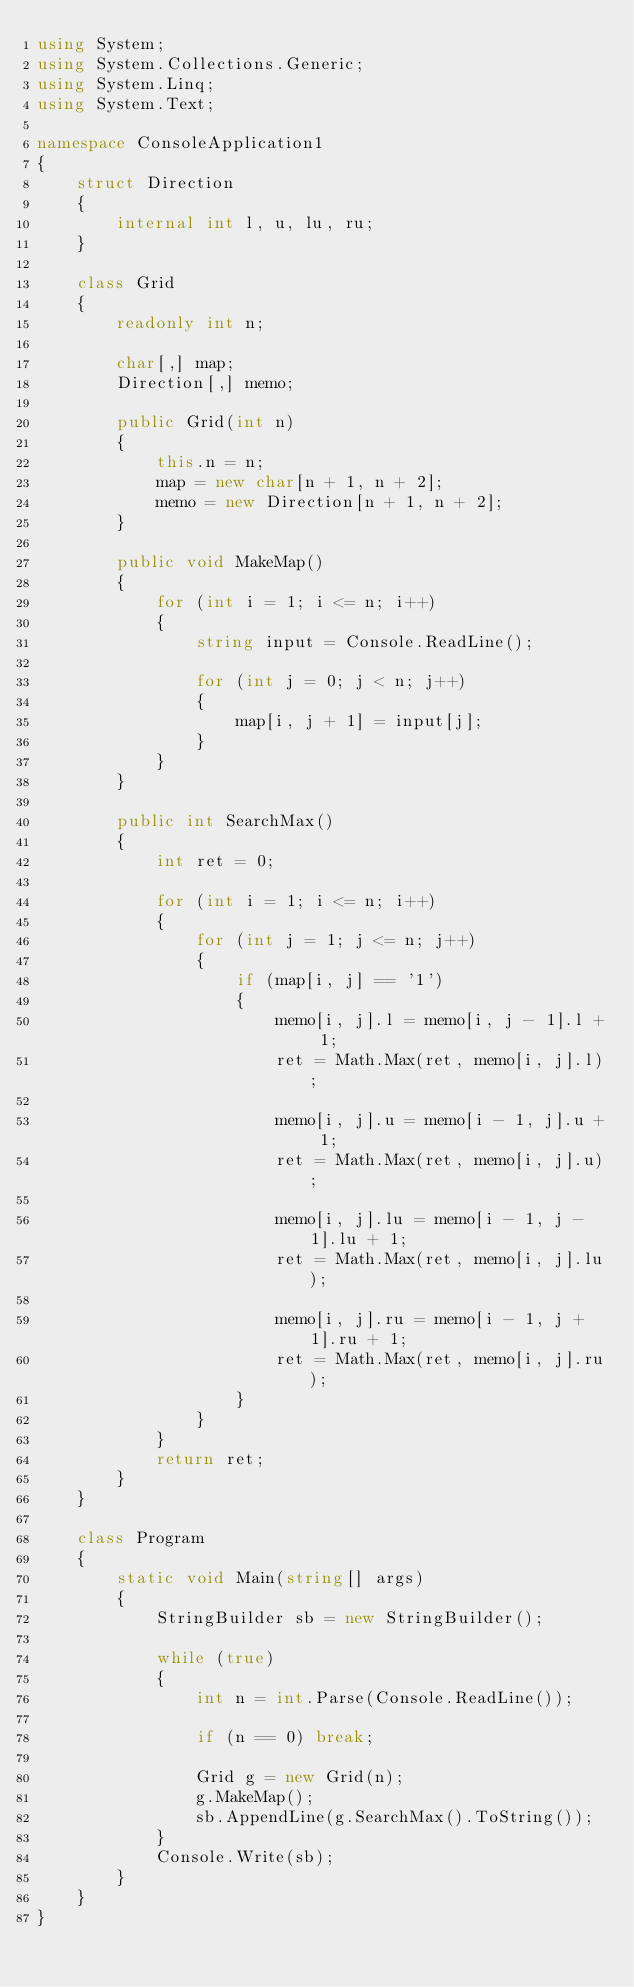<code> <loc_0><loc_0><loc_500><loc_500><_C#_>using System;
using System.Collections.Generic;
using System.Linq;
using System.Text;

namespace ConsoleApplication1
{
    struct Direction
    {
        internal int l, u, lu, ru;
    }

    class Grid
    {
        readonly int n;

        char[,] map;
        Direction[,] memo;

        public Grid(int n)
        {
            this.n = n;
            map = new char[n + 1, n + 2];
            memo = new Direction[n + 1, n + 2];
        }

        public void MakeMap()
        {
            for (int i = 1; i <= n; i++)
            {
                string input = Console.ReadLine();

                for (int j = 0; j < n; j++)
                {
                    map[i, j + 1] = input[j];
                }
            }
        }

        public int SearchMax()
        {
            int ret = 0;

            for (int i = 1; i <= n; i++)
            {
                for (int j = 1; j <= n; j++)
                {
                    if (map[i, j] == '1')
                    {
                        memo[i, j].l = memo[i, j - 1].l + 1;
                        ret = Math.Max(ret, memo[i, j].l);

                        memo[i, j].u = memo[i - 1, j].u + 1;
                        ret = Math.Max(ret, memo[i, j].u);

                        memo[i, j].lu = memo[i - 1, j - 1].lu + 1;
                        ret = Math.Max(ret, memo[i, j].lu);

                        memo[i, j].ru = memo[i - 1, j + 1].ru + 1;
                        ret = Math.Max(ret, memo[i, j].ru);
                    }
                }
            }
            return ret;
        }
    }

    class Program
    {
        static void Main(string[] args)
        {
            StringBuilder sb = new StringBuilder();

            while (true)
            {
                int n = int.Parse(Console.ReadLine());

                if (n == 0) break;

                Grid g = new Grid(n);
                g.MakeMap();
                sb.AppendLine(g.SearchMax().ToString());
            }
            Console.Write(sb);
        }
    }
}</code> 